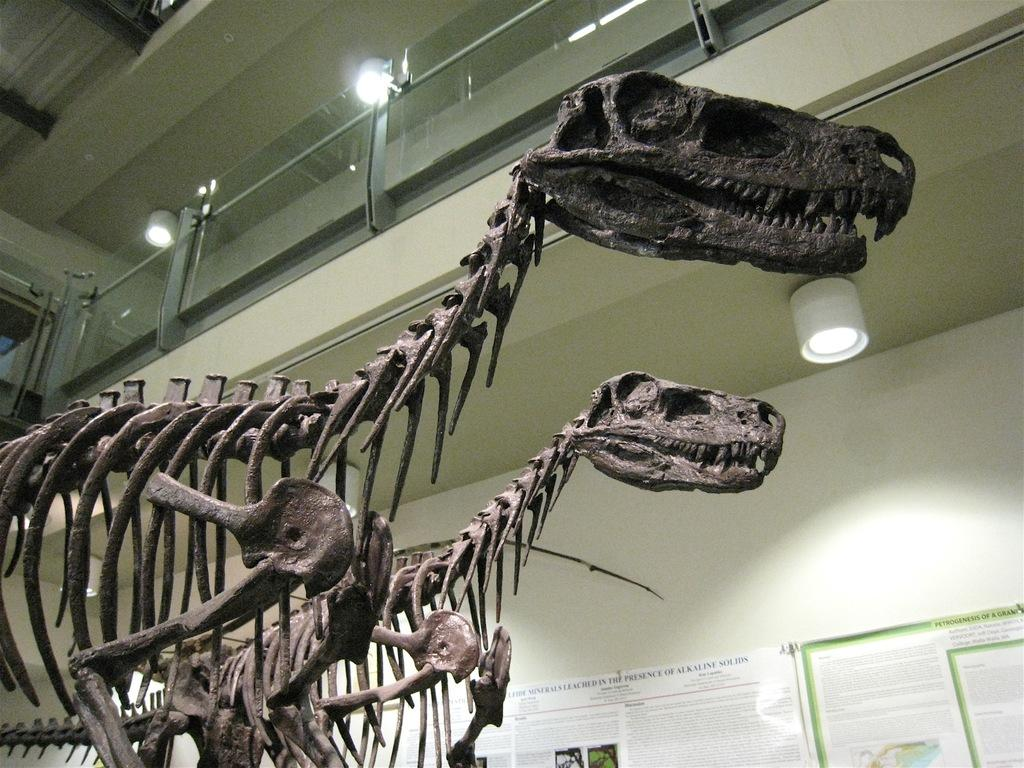What type of skeletons can be seen on the floor in the image? There are skeletons of tyrannosaurus on the floor. What can be seen on the wall in the background of the image? There are posters on the wall in the background. What is attached to the roofs in the background of the image? There are lights attached to the roofs in the background. What type of fencing is present in the background of the image? There is glass fencing in the background. Can you see any muscles on the tyrannosaurus skeletons in the image? No, the image only shows the skeletons of the tyrannosaurus, which do not include muscles. What type of rabbit can be seen hopping around in the image? There are no rabbits present in the image. 